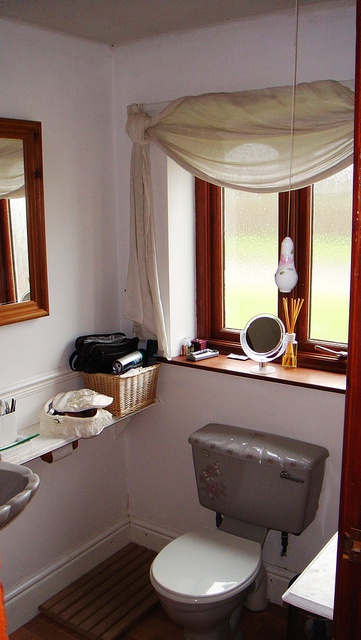Describe the objects in this image and their specific colors. I can see toilet in gray, black, and darkgray tones and sink in gray, black, and darkgray tones in this image. 